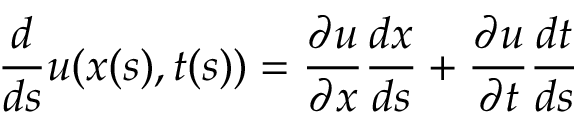Convert formula to latex. <formula><loc_0><loc_0><loc_500><loc_500>{ \frac { d } { d s } } u ( x ( s ) , t ( s ) ) = { \frac { \partial u } { \partial x } } { \frac { d x } { d s } } + { \frac { \partial u } { \partial t } } { \frac { d t } { d s } }</formula> 